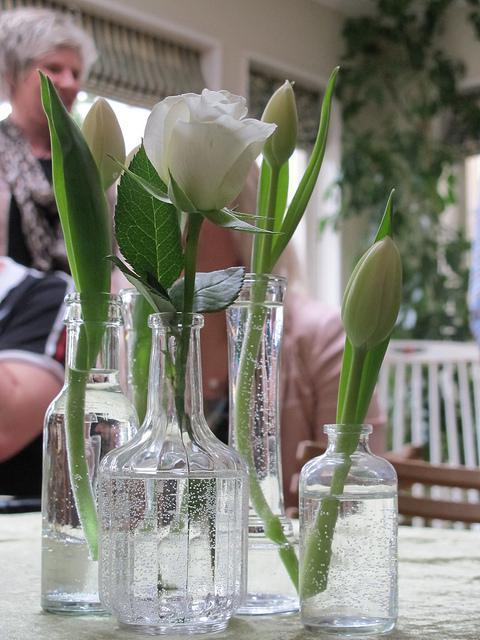How many vases that has a rose in it?
Give a very brief answer. 1. How many people are visible?
Give a very brief answer. 3. How many vases can you see?
Give a very brief answer. 4. 